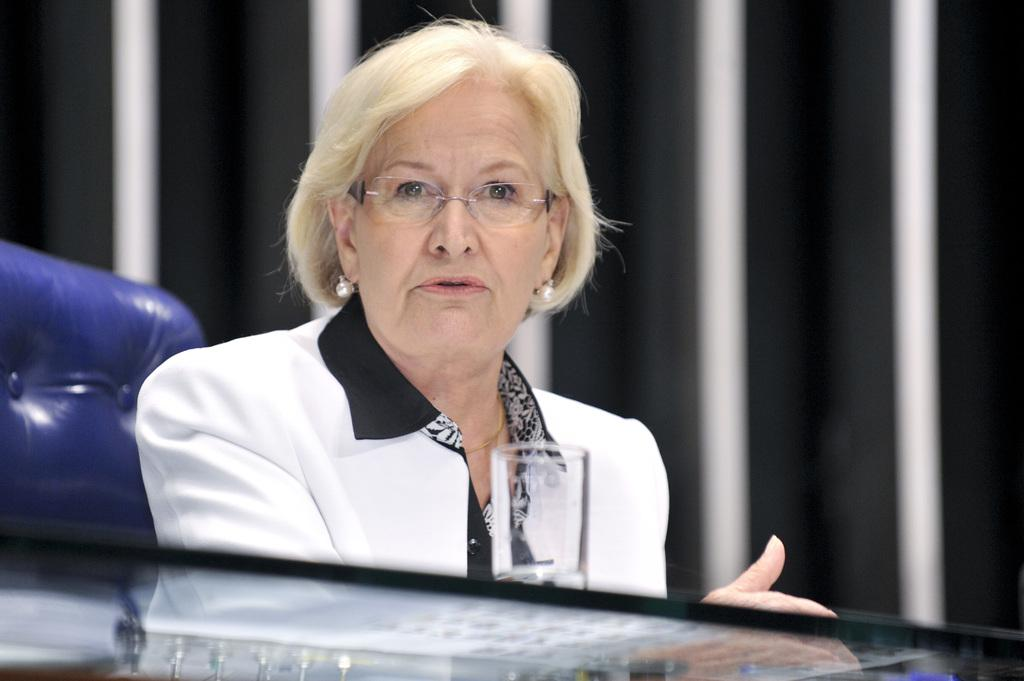Who is the main subject in the image? There is an old woman in the image. What is the old woman doing in the image? The old woman is sitting on a chair. What type of furniture is present in the image? There is a glass table in the image. Can you describe the background of the image? The background of the image is blurred. What type of oatmeal is the old woman eating in the image? There is no oatmeal present in the image, and the old woman is not eating anything. What stage of development is the old woman in the image? The image does not provide information about the old woman's developmental stage. 